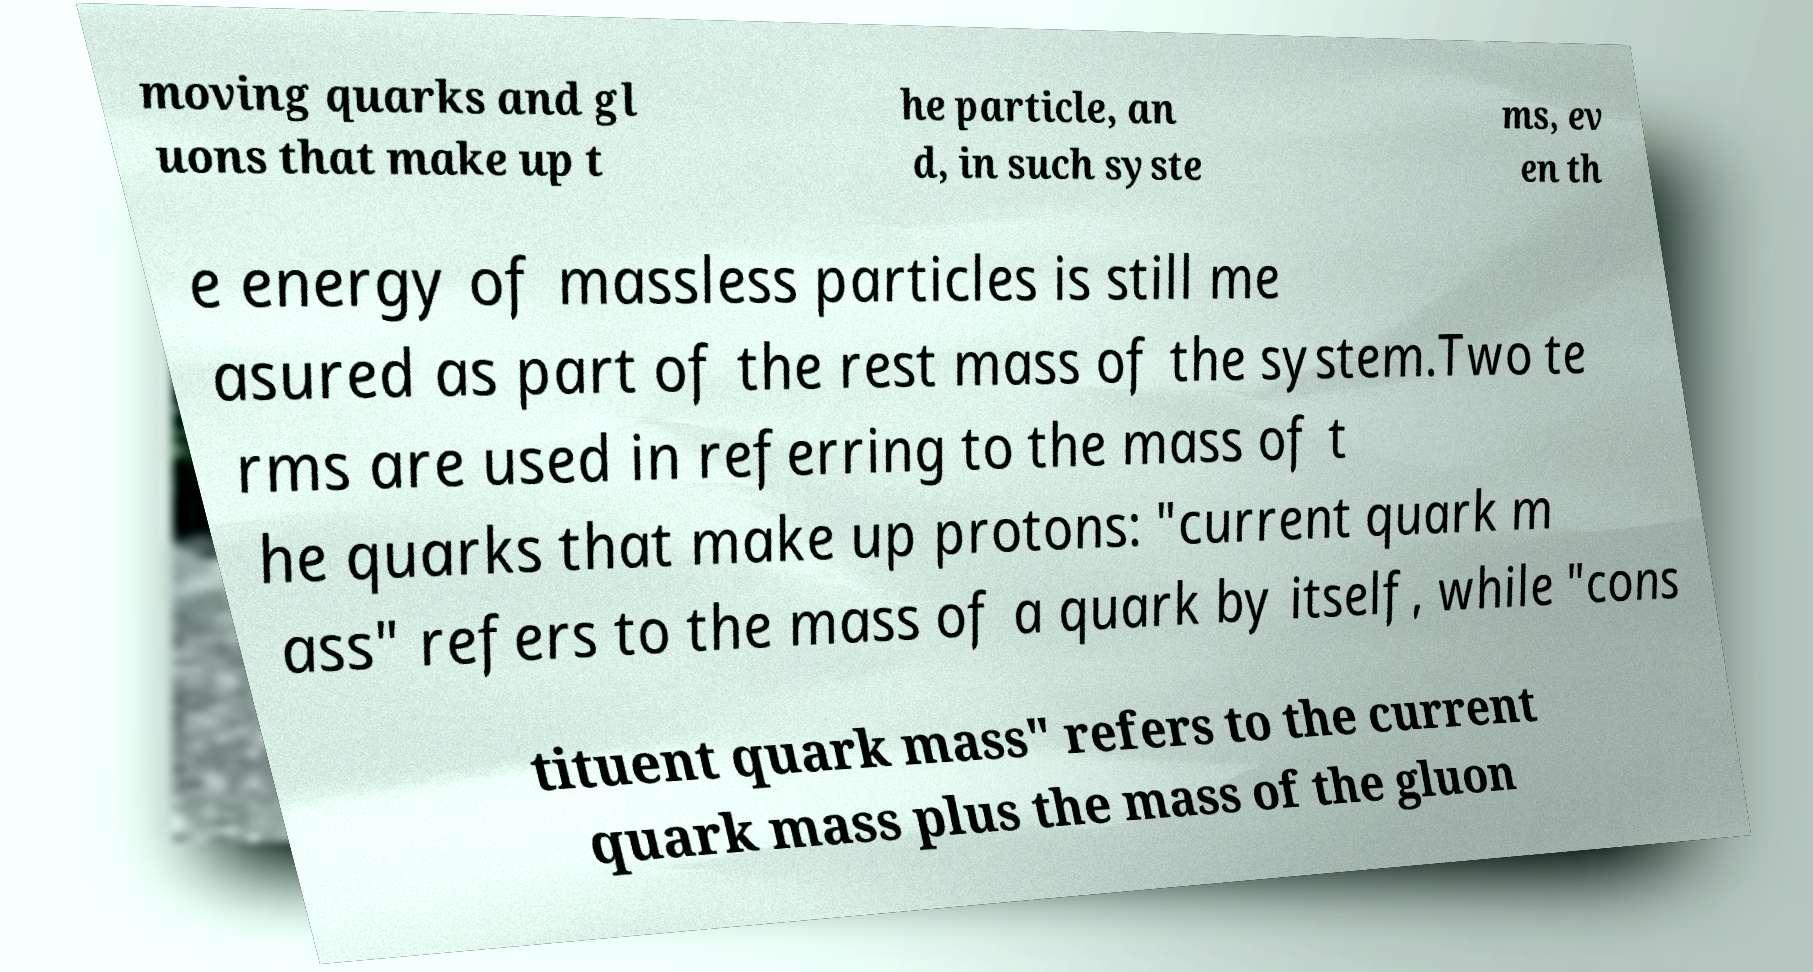Could you assist in decoding the text presented in this image and type it out clearly? moving quarks and gl uons that make up t he particle, an d, in such syste ms, ev en th e energy of massless particles is still me asured as part of the rest mass of the system.Two te rms are used in referring to the mass of t he quarks that make up protons: "current quark m ass" refers to the mass of a quark by itself, while "cons tituent quark mass" refers to the current quark mass plus the mass of the gluon 